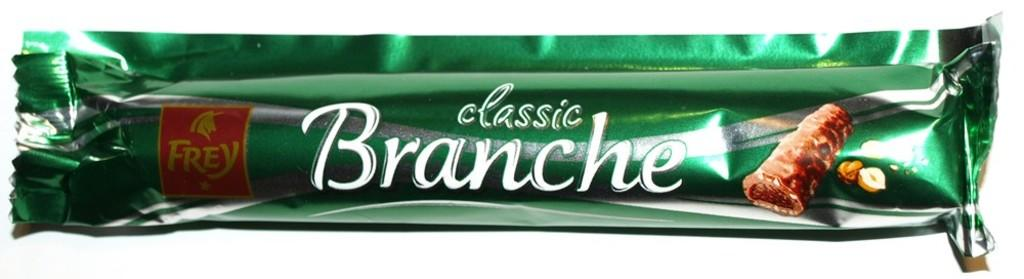<image>
Render a clear and concise summary of the photo. A Classic Branche candy bar with a white background 